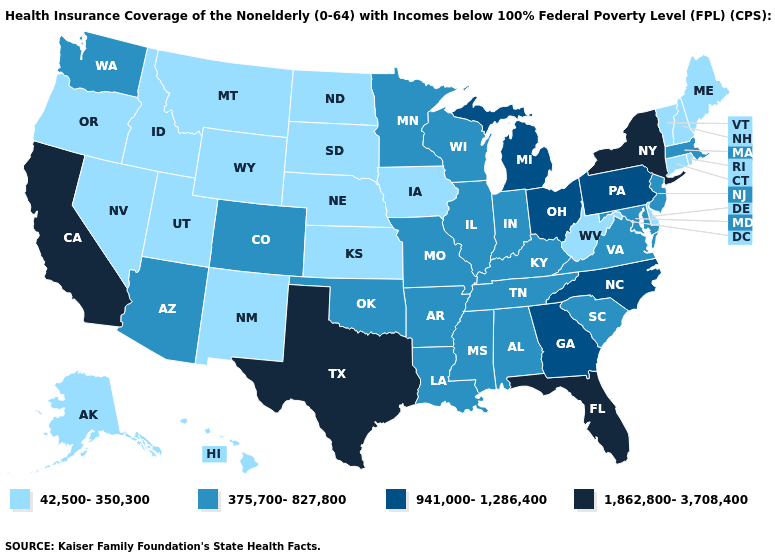Name the states that have a value in the range 375,700-827,800?
Answer briefly. Alabama, Arizona, Arkansas, Colorado, Illinois, Indiana, Kentucky, Louisiana, Maryland, Massachusetts, Minnesota, Mississippi, Missouri, New Jersey, Oklahoma, South Carolina, Tennessee, Virginia, Washington, Wisconsin. What is the lowest value in the West?
Quick response, please. 42,500-350,300. Which states have the lowest value in the MidWest?
Give a very brief answer. Iowa, Kansas, Nebraska, North Dakota, South Dakota. Among the states that border Wisconsin , which have the lowest value?
Give a very brief answer. Iowa. Name the states that have a value in the range 1,862,800-3,708,400?
Keep it brief. California, Florida, New York, Texas. What is the value of Vermont?
Be succinct. 42,500-350,300. Does New Hampshire have the same value as Wyoming?
Concise answer only. Yes. What is the value of Nevada?
Write a very short answer. 42,500-350,300. Name the states that have a value in the range 375,700-827,800?
Answer briefly. Alabama, Arizona, Arkansas, Colorado, Illinois, Indiana, Kentucky, Louisiana, Maryland, Massachusetts, Minnesota, Mississippi, Missouri, New Jersey, Oklahoma, South Carolina, Tennessee, Virginia, Washington, Wisconsin. Does the map have missing data?
Write a very short answer. No. What is the value of North Dakota?
Give a very brief answer. 42,500-350,300. What is the value of North Carolina?
Quick response, please. 941,000-1,286,400. Name the states that have a value in the range 42,500-350,300?
Keep it brief. Alaska, Connecticut, Delaware, Hawaii, Idaho, Iowa, Kansas, Maine, Montana, Nebraska, Nevada, New Hampshire, New Mexico, North Dakota, Oregon, Rhode Island, South Dakota, Utah, Vermont, West Virginia, Wyoming. 